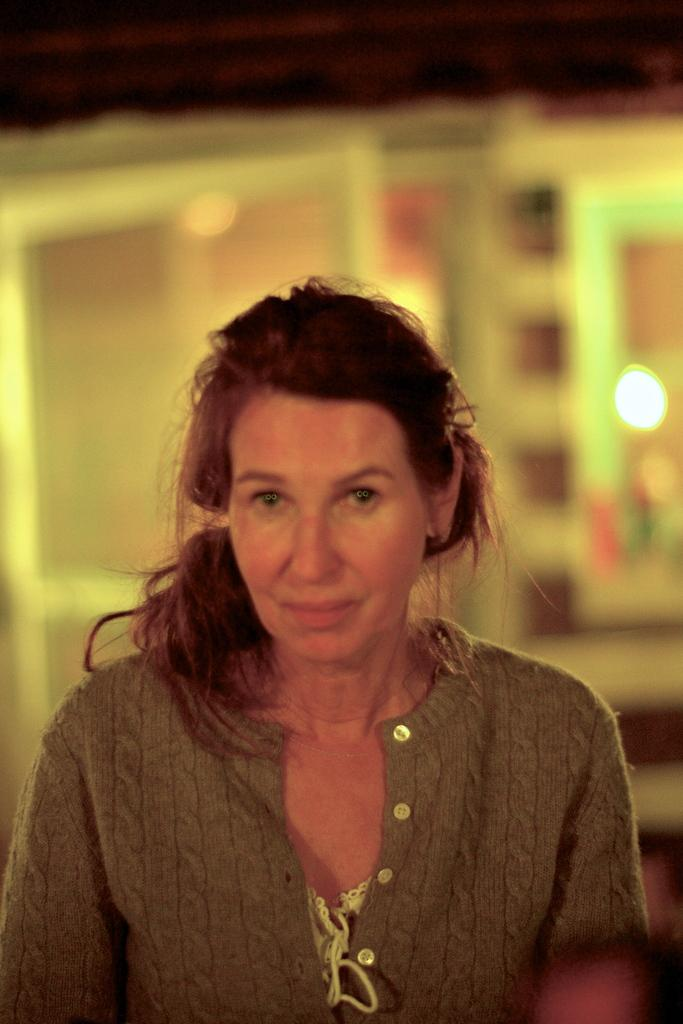What can be observed about the background of the image? The background portion of the picture is blurred. What structure is present in the image? There is a door in the image. Who is in the image? There is a woman in the image. What type of hose is being used by the woman in the image? There is no hose present in the image. Can you tell me the relationship between the woman and her father in the image? There is no information about the woman's father in the image. 